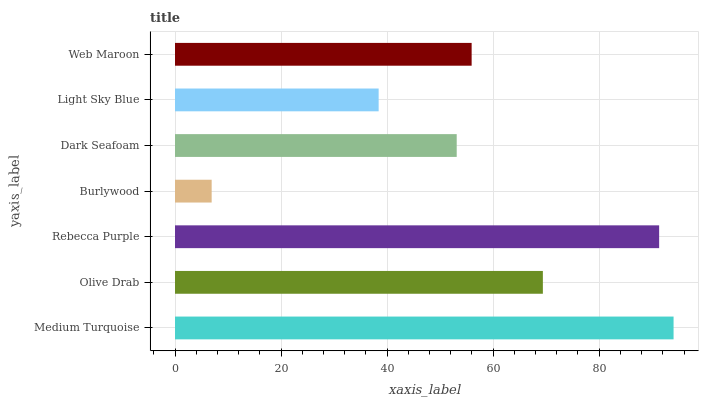Is Burlywood the minimum?
Answer yes or no. Yes. Is Medium Turquoise the maximum?
Answer yes or no. Yes. Is Olive Drab the minimum?
Answer yes or no. No. Is Olive Drab the maximum?
Answer yes or no. No. Is Medium Turquoise greater than Olive Drab?
Answer yes or no. Yes. Is Olive Drab less than Medium Turquoise?
Answer yes or no. Yes. Is Olive Drab greater than Medium Turquoise?
Answer yes or no. No. Is Medium Turquoise less than Olive Drab?
Answer yes or no. No. Is Web Maroon the high median?
Answer yes or no. Yes. Is Web Maroon the low median?
Answer yes or no. Yes. Is Light Sky Blue the high median?
Answer yes or no. No. Is Light Sky Blue the low median?
Answer yes or no. No. 